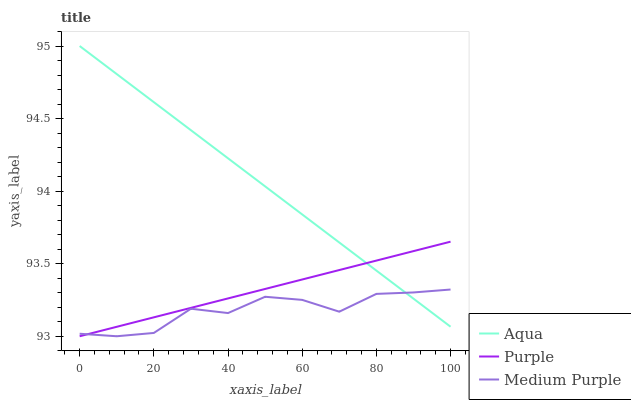Does Aqua have the minimum area under the curve?
Answer yes or no. No. Does Medium Purple have the maximum area under the curve?
Answer yes or no. No. Is Medium Purple the smoothest?
Answer yes or no. No. Is Aqua the roughest?
Answer yes or no. No. Does Aqua have the lowest value?
Answer yes or no. No. Does Medium Purple have the highest value?
Answer yes or no. No. 